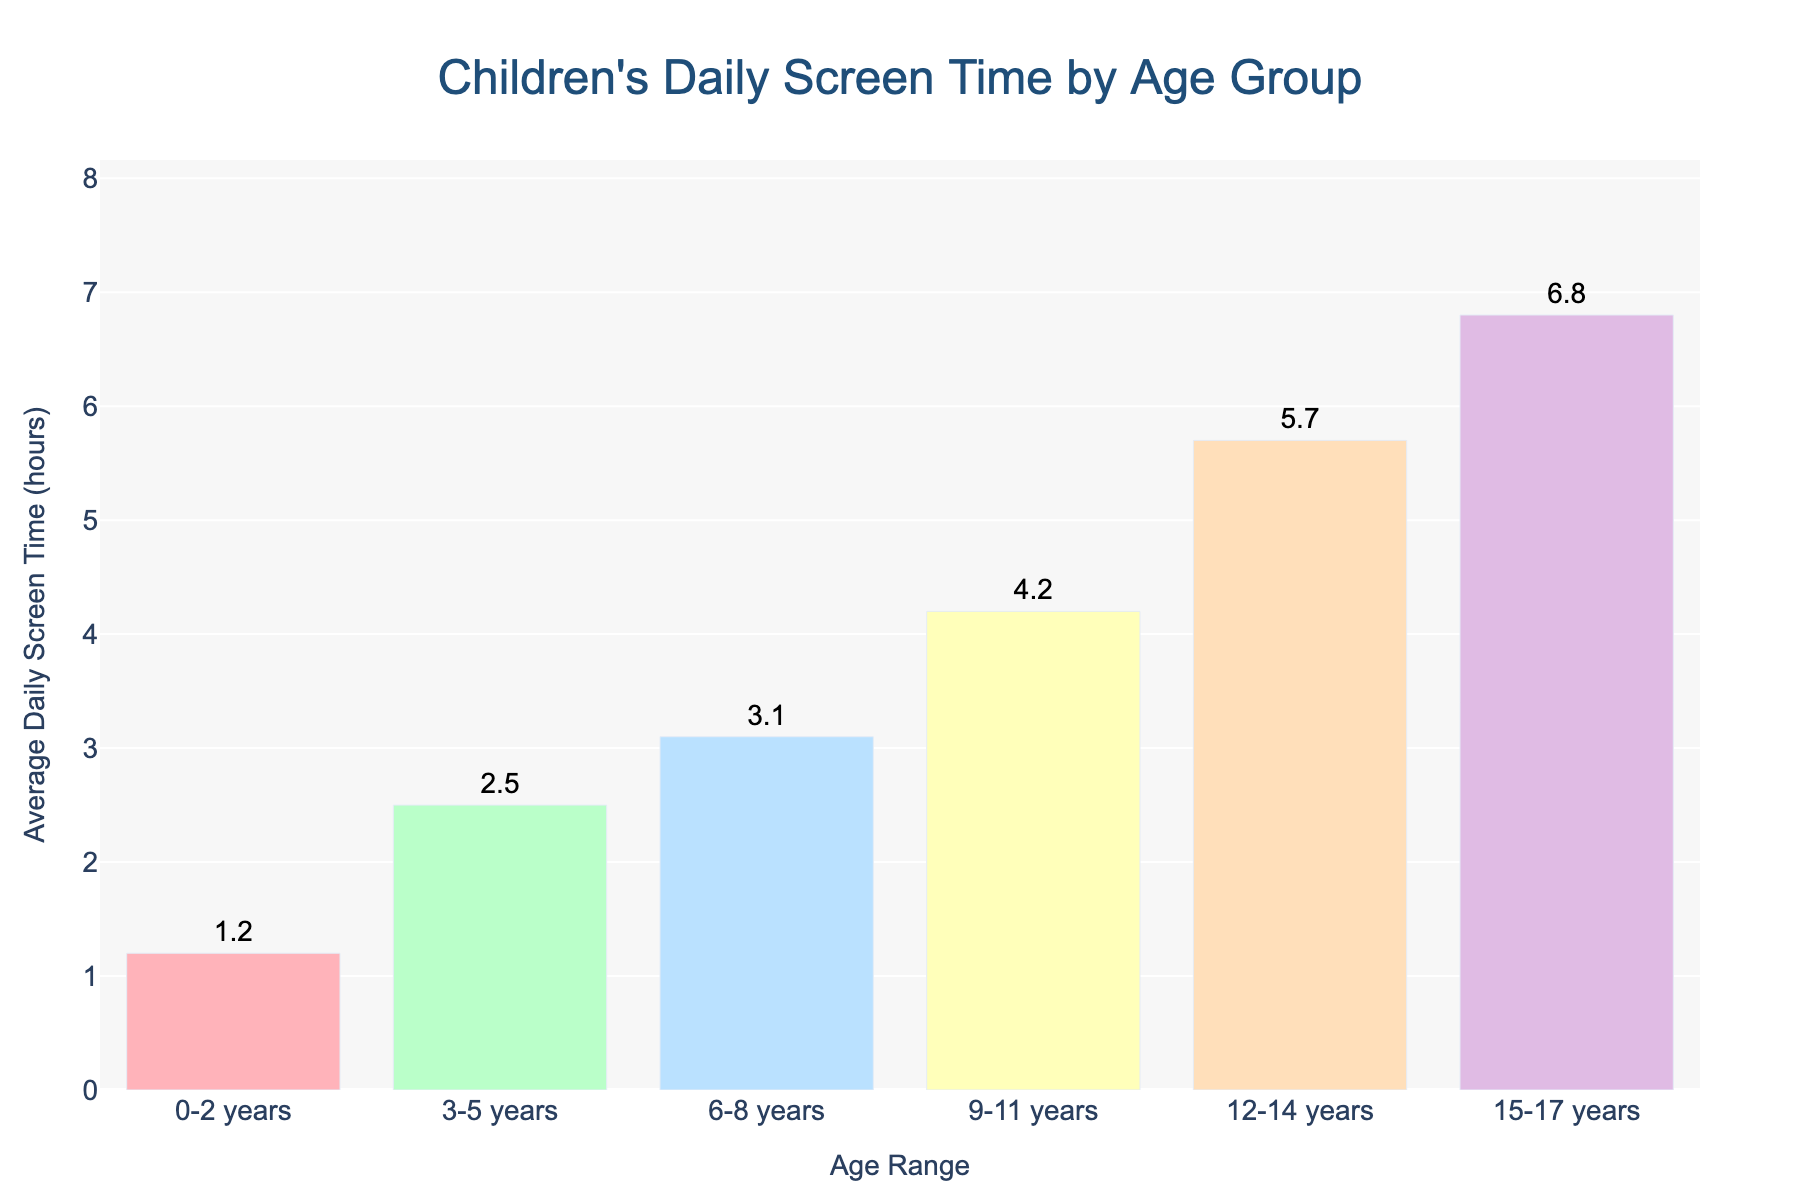What is the age range with the highest average daily screen time? Look at the bar with the greatest height on the chart, which corresponds to the '15-17 years' age range with 6.8 hours.
Answer: 15-17 years What is the difference in average daily screen time between 0-2 years and 15-17 years? Subtract the average daily screen time for '0-2 years' (1.2 hours) from the screen time for '15-17 years' (6.8 hours). The difference is 6.8 - 1.2 = 5.6 hours.
Answer: 5.6 hours What is the total average daily screen time for children aged between 6 and 14 years? Add the average daily screen times for '6-8 years' (3.1 hours), '9-11 years' (4.2 hours), and '12-14 years' (5.7 hours). The total is 3.1 + 4.2 + 5.7 = 13.0 hours.
Answer: 13.0 hours Which age range spends around double the screen time than the '3-5 years' group? '3-5 years' group spends 2.5 hours. Double of 2.5 is 5.0 hours. The '12-14 years' group spends 5.7 hours, which is closest to and slightly more than double.
Answer: 12-14 years Are the screen times for the '0-2 years' and '3-5 years' groups less than the screen time for the '9-11 years' group? Add the screen times for '0-2 years' (1.2 hours) and '3-5 years' (2.5 hours). The total is 1.2 + 2.5 = 3.7 hours, which is less than 4.2 hours for '9-11 years'.
Answer: Yes Which age range has the closest average daily screen time to 4 hours? Find the bar with an average daily screen time closest to 4 hours. The '9-11 years' group spends 4.2 hours, which is closest to 4 hours.
Answer: 9-11 years What colors are used for the age groups '0-2 years' and '15-17 years'? '0-2 years' group is colored in pink, and '15-17 years' group is colored in purple.
Answer: Pink and purple Is the average screen time for the '12-14 years' group more than 3 times that of the '0-2 years' group? '12-14 years' group spends 5.7 hours, '0-2 years' spends 1.2 hours. 3 times of 1.2 is 3.6. Since 5.7 is greater than 3.6, the answer is yes.
Answer: Yes 